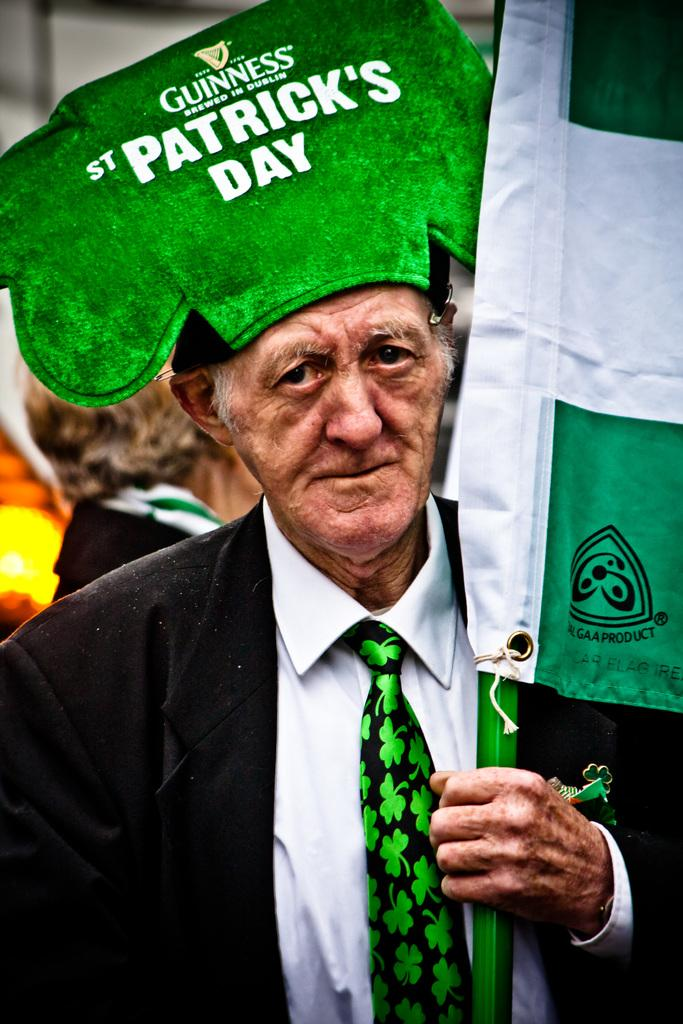How many people are in the image? There is a group of persons in the image. Can you describe the clothing or accessories of one of the persons? One person is wearing a cap with some text. What is the person with the cap holding in his hand? The person with the cap is holding a flag in his hand. Is the person with the cap playing a guitar in the image? There is no guitar present in the image. Does the person with the cap have a sister in the image? The provided facts do not mention any siblings or relationships between the persons in the image. 